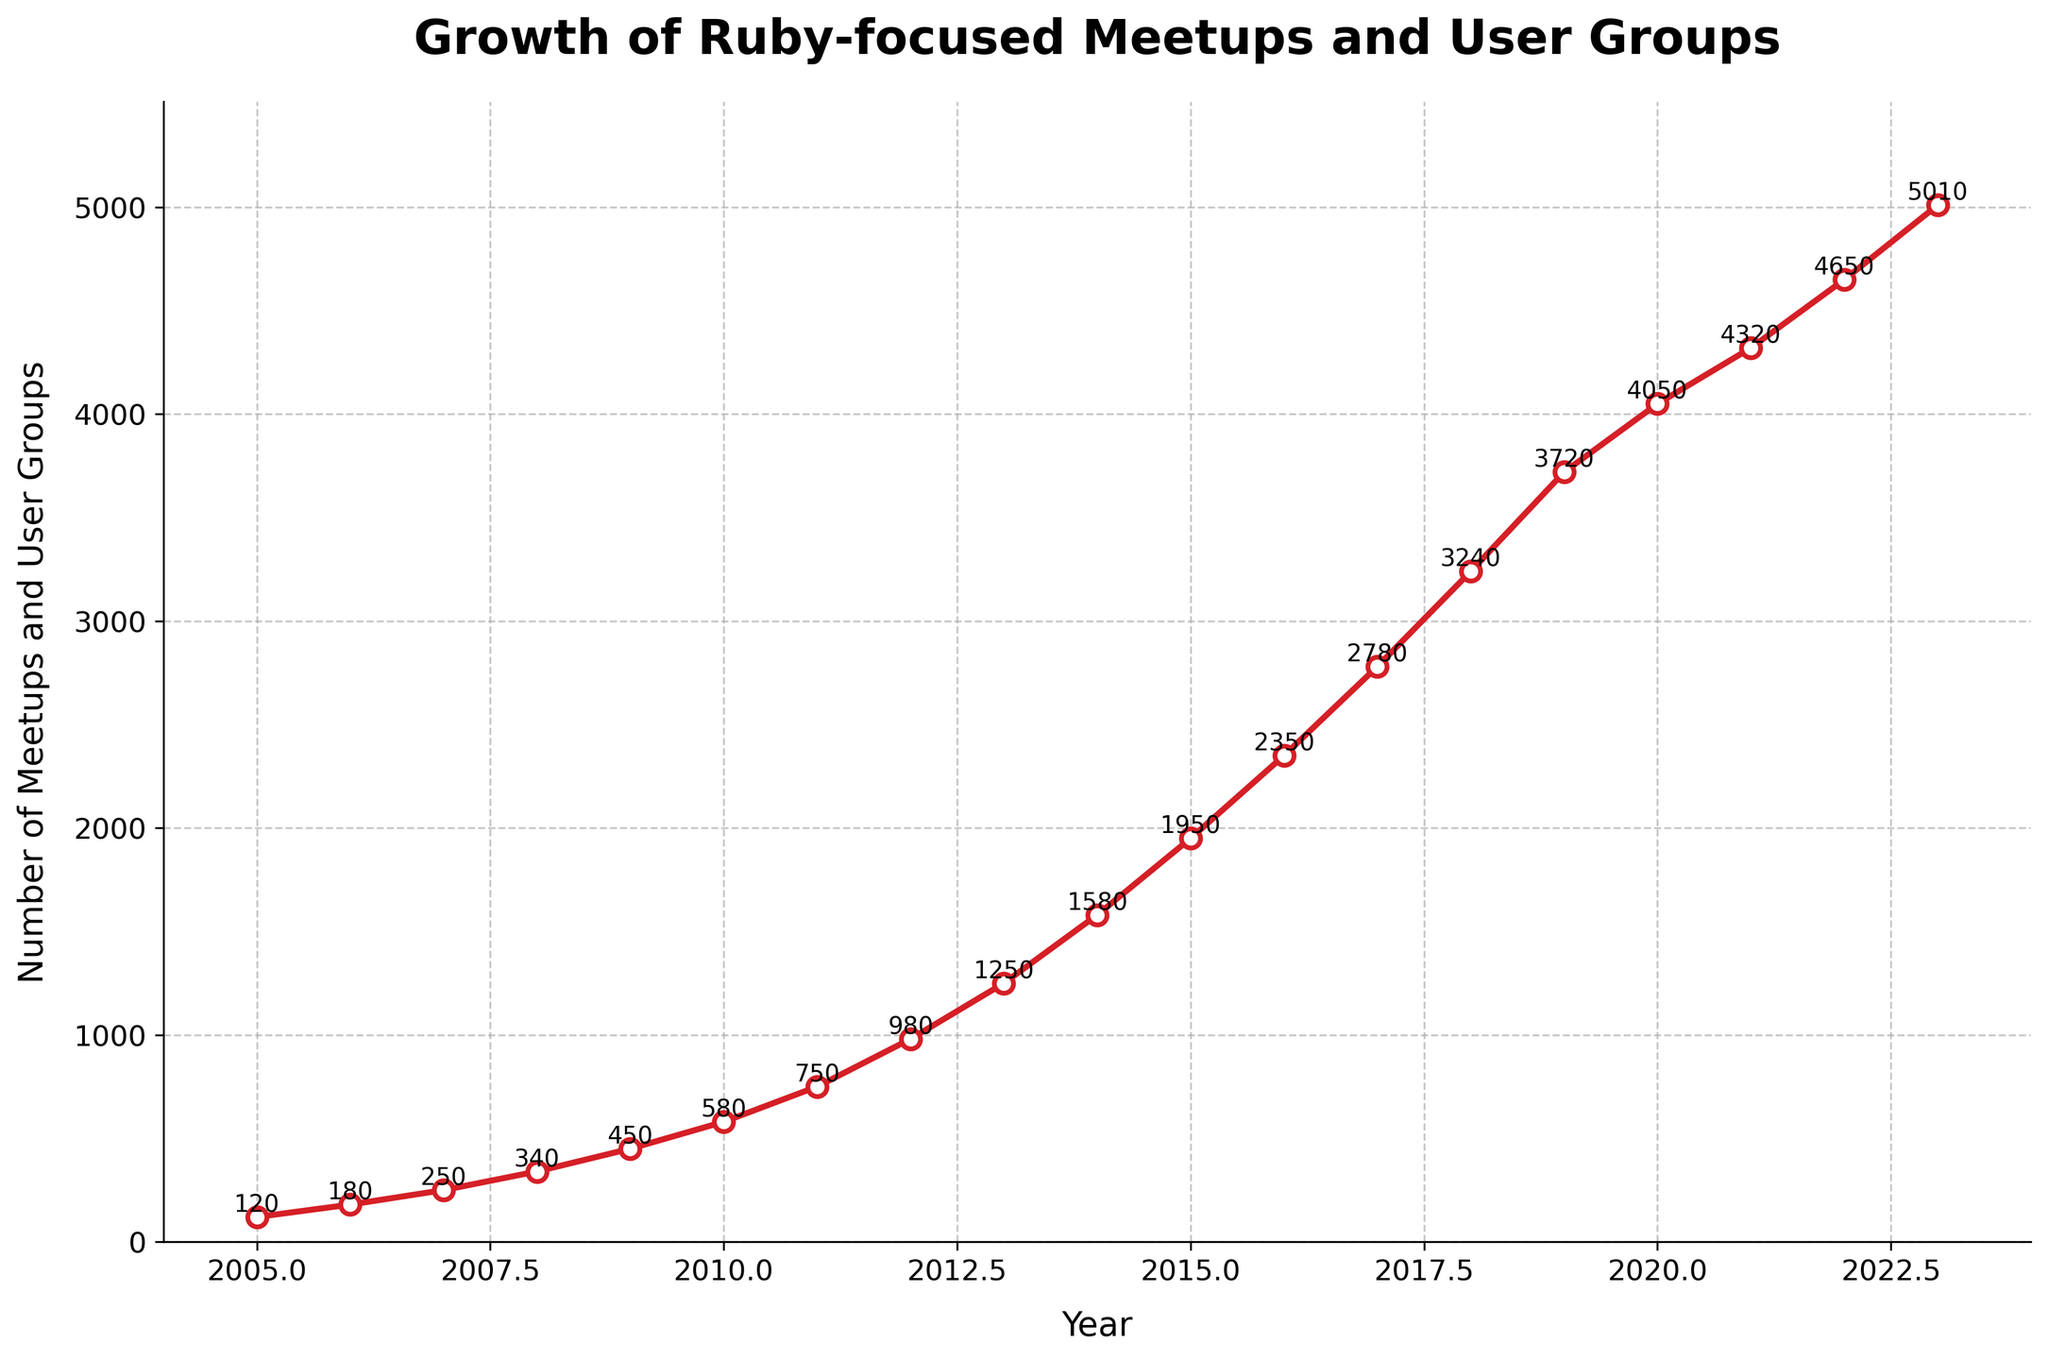What year saw the most significant increase in the number of meetups and user groups compared to the previous year? To determine the year with the most significant increase, look at the difference in numbers from one year to the next. Calculate ∆Meetups for each year and find the year with the largest ∆. From 2012 to 2013 (1250 - 980 = 270), which is the largest increase.
Answer: 2012 to 2013 Which year had the smallest number of Ruby-focused meetups and user groups, and what was the number? Identify the year with the lowest value on the Y-axis and read the corresponding value. The year 2005 has the smallest number, which is 120.
Answer: 2005, 120 How many meetups and user groups were there in 2017, and how does this compare to 2015? Find the values for 2017 and 2015 directly from the graph. There were 2780 meetups in 2017 and 1950 in 2015.
Answer: 2017: 2780, 2015: 1950 What is the total growth in the number of meetups from 2005 to 2023? Subtract the number of meetups in 2005 from the number of meetups in 2023 to get the total growth. (5010 in 2023 - 120 in 2005 = 4890)
Answer: 4890 On average, how many new meetups and user groups were added each year between 2005 and 2023? Calculate the average growth per year by dividing the total growth by the number of years. Total growth (5010 - 120 = 4890) over 18 years (2023 - 2005) is 4890 / 18 ≈ 271.67.
Answer: ≈ 271.67 In what range of years did the meetups and user groups number surpass 3000 for the first time? Look at the graph for the first year the value exceeds 3000. The number first surpasses 3000 in 2018.
Answer: 2018 Is the growth in the number of meetups and user groups linear or non-linear? By observing the curve of the line in the graph, we notice it steepens and escalates more sharply after initial years, indicating non-linear growth.
Answer: Non-linear What were the number of meetups and user groups in 2010 and in 2011, and what is the percentage increase from 2010 to 2011? Find values for 2010 and 2011 and calculate the percentage increase. (750 - 580) / 580 * 100 ≈ 29.31%.
Answer: 2010: 580, 2011: 750, ≈ 29.31% During which consecutive years did the number of meetups first double, and what were the values? Calculate which consecutive years saw the first doubling of meetups. From 2005 to 2008, meetups went from 120 to 340, almost tripling. Exact doubling does not occur but most significant growth is seen in early years.
Answer: 2005-2008, 120-340 What is the difference in the number of meetups and user groups between the highest point and the lowest point on the graph? Find the highest value (5010 in 2023) and the lowest value (120 in 2005) and subtract to get the difference. 5010 - 120 = 4890.
Answer: 4890 